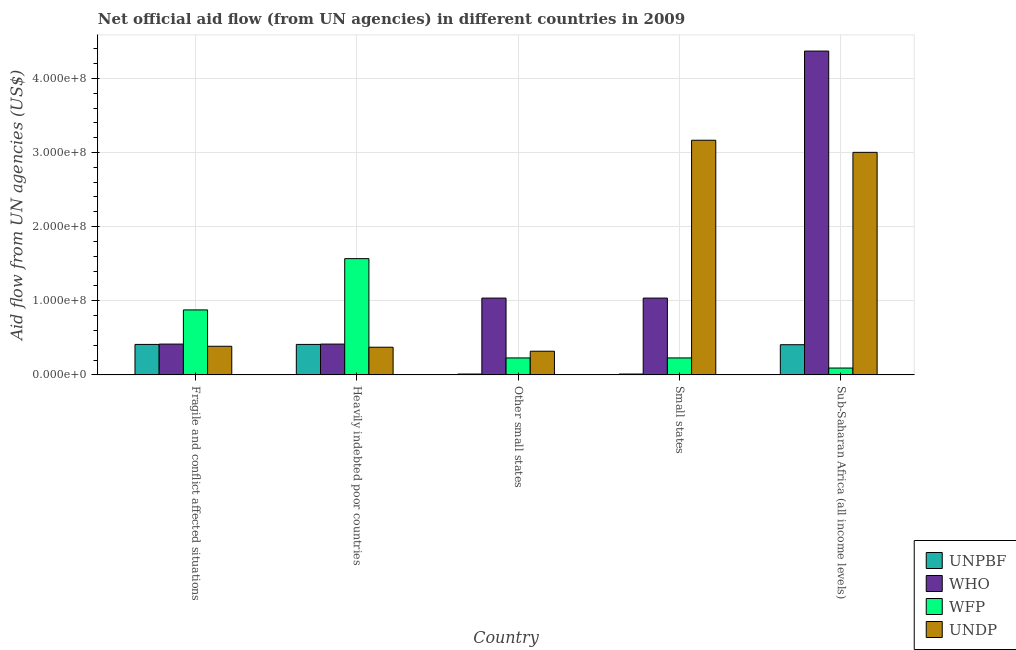How many different coloured bars are there?
Offer a terse response. 4. How many groups of bars are there?
Provide a succinct answer. 5. Are the number of bars per tick equal to the number of legend labels?
Your answer should be very brief. Yes. How many bars are there on the 5th tick from the left?
Offer a terse response. 4. How many bars are there on the 5th tick from the right?
Provide a succinct answer. 4. What is the label of the 3rd group of bars from the left?
Give a very brief answer. Other small states. What is the amount of aid given by unpbf in Small states?
Offer a terse response. 1.18e+06. Across all countries, what is the maximum amount of aid given by unpbf?
Give a very brief answer. 4.11e+07. Across all countries, what is the minimum amount of aid given by undp?
Make the answer very short. 3.20e+07. In which country was the amount of aid given by who maximum?
Your answer should be compact. Sub-Saharan Africa (all income levels). In which country was the amount of aid given by wfp minimum?
Your response must be concise. Sub-Saharan Africa (all income levels). What is the total amount of aid given by unpbf in the graph?
Your answer should be compact. 1.25e+08. What is the difference between the amount of aid given by undp in Small states and that in Sub-Saharan Africa (all income levels)?
Provide a succinct answer. 1.63e+07. What is the difference between the amount of aid given by wfp in Sub-Saharan Africa (all income levels) and the amount of aid given by who in Heavily indebted poor countries?
Offer a terse response. -3.23e+07. What is the average amount of aid given by wfp per country?
Your response must be concise. 5.99e+07. What is the difference between the amount of aid given by who and amount of aid given by wfp in Heavily indebted poor countries?
Your answer should be compact. -1.15e+08. In how many countries, is the amount of aid given by who greater than 420000000 US$?
Offer a terse response. 1. What is the ratio of the amount of aid given by unpbf in Heavily indebted poor countries to that in Small states?
Your answer should be very brief. 34.86. What is the difference between the highest and the second highest amount of aid given by who?
Give a very brief answer. 3.33e+08. What is the difference between the highest and the lowest amount of aid given by wfp?
Your response must be concise. 1.48e+08. In how many countries, is the amount of aid given by wfp greater than the average amount of aid given by wfp taken over all countries?
Your response must be concise. 2. Is the sum of the amount of aid given by who in Fragile and conflict affected situations and Other small states greater than the maximum amount of aid given by undp across all countries?
Offer a terse response. No. What does the 2nd bar from the left in Sub-Saharan Africa (all income levels) represents?
Provide a short and direct response. WHO. What does the 4th bar from the right in Small states represents?
Ensure brevity in your answer.  UNPBF. How many bars are there?
Your answer should be very brief. 20. Are all the bars in the graph horizontal?
Offer a very short reply. No. Are the values on the major ticks of Y-axis written in scientific E-notation?
Your answer should be compact. Yes. Does the graph contain grids?
Make the answer very short. Yes. Where does the legend appear in the graph?
Give a very brief answer. Bottom right. How are the legend labels stacked?
Provide a succinct answer. Vertical. What is the title of the graph?
Ensure brevity in your answer.  Net official aid flow (from UN agencies) in different countries in 2009. What is the label or title of the X-axis?
Give a very brief answer. Country. What is the label or title of the Y-axis?
Offer a very short reply. Aid flow from UN agencies (US$). What is the Aid flow from UN agencies (US$) of UNPBF in Fragile and conflict affected situations?
Ensure brevity in your answer.  4.11e+07. What is the Aid flow from UN agencies (US$) in WHO in Fragile and conflict affected situations?
Give a very brief answer. 4.16e+07. What is the Aid flow from UN agencies (US$) in WFP in Fragile and conflict affected situations?
Offer a very short reply. 8.77e+07. What is the Aid flow from UN agencies (US$) of UNDP in Fragile and conflict affected situations?
Make the answer very short. 3.86e+07. What is the Aid flow from UN agencies (US$) in UNPBF in Heavily indebted poor countries?
Ensure brevity in your answer.  4.11e+07. What is the Aid flow from UN agencies (US$) in WHO in Heavily indebted poor countries?
Ensure brevity in your answer.  4.16e+07. What is the Aid flow from UN agencies (US$) in WFP in Heavily indebted poor countries?
Offer a terse response. 1.57e+08. What is the Aid flow from UN agencies (US$) in UNDP in Heavily indebted poor countries?
Offer a very short reply. 3.74e+07. What is the Aid flow from UN agencies (US$) in UNPBF in Other small states?
Offer a very short reply. 1.18e+06. What is the Aid flow from UN agencies (US$) in WHO in Other small states?
Keep it short and to the point. 1.04e+08. What is the Aid flow from UN agencies (US$) in WFP in Other small states?
Your response must be concise. 2.29e+07. What is the Aid flow from UN agencies (US$) of UNDP in Other small states?
Offer a terse response. 3.20e+07. What is the Aid flow from UN agencies (US$) of UNPBF in Small states?
Provide a succinct answer. 1.18e+06. What is the Aid flow from UN agencies (US$) of WHO in Small states?
Make the answer very short. 1.04e+08. What is the Aid flow from UN agencies (US$) in WFP in Small states?
Provide a succinct answer. 2.29e+07. What is the Aid flow from UN agencies (US$) of UNDP in Small states?
Your response must be concise. 3.17e+08. What is the Aid flow from UN agencies (US$) of UNPBF in Sub-Saharan Africa (all income levels)?
Give a very brief answer. 4.07e+07. What is the Aid flow from UN agencies (US$) in WHO in Sub-Saharan Africa (all income levels)?
Your answer should be very brief. 4.37e+08. What is the Aid flow from UN agencies (US$) in WFP in Sub-Saharan Africa (all income levels)?
Offer a terse response. 9.28e+06. What is the Aid flow from UN agencies (US$) in UNDP in Sub-Saharan Africa (all income levels)?
Offer a terse response. 3.00e+08. Across all countries, what is the maximum Aid flow from UN agencies (US$) of UNPBF?
Offer a very short reply. 4.11e+07. Across all countries, what is the maximum Aid flow from UN agencies (US$) of WHO?
Your answer should be very brief. 4.37e+08. Across all countries, what is the maximum Aid flow from UN agencies (US$) in WFP?
Give a very brief answer. 1.57e+08. Across all countries, what is the maximum Aid flow from UN agencies (US$) in UNDP?
Your answer should be very brief. 3.17e+08. Across all countries, what is the minimum Aid flow from UN agencies (US$) in UNPBF?
Offer a terse response. 1.18e+06. Across all countries, what is the minimum Aid flow from UN agencies (US$) in WHO?
Keep it short and to the point. 4.16e+07. Across all countries, what is the minimum Aid flow from UN agencies (US$) in WFP?
Provide a short and direct response. 9.28e+06. Across all countries, what is the minimum Aid flow from UN agencies (US$) in UNDP?
Your answer should be very brief. 3.20e+07. What is the total Aid flow from UN agencies (US$) in UNPBF in the graph?
Your response must be concise. 1.25e+08. What is the total Aid flow from UN agencies (US$) in WHO in the graph?
Your answer should be very brief. 7.27e+08. What is the total Aid flow from UN agencies (US$) of WFP in the graph?
Your answer should be very brief. 3.00e+08. What is the total Aid flow from UN agencies (US$) of UNDP in the graph?
Your answer should be very brief. 7.25e+08. What is the difference between the Aid flow from UN agencies (US$) of UNPBF in Fragile and conflict affected situations and that in Heavily indebted poor countries?
Your answer should be very brief. 0. What is the difference between the Aid flow from UN agencies (US$) of WFP in Fragile and conflict affected situations and that in Heavily indebted poor countries?
Offer a terse response. -6.92e+07. What is the difference between the Aid flow from UN agencies (US$) in UNDP in Fragile and conflict affected situations and that in Heavily indebted poor countries?
Offer a terse response. 1.28e+06. What is the difference between the Aid flow from UN agencies (US$) in UNPBF in Fragile and conflict affected situations and that in Other small states?
Your answer should be compact. 4.00e+07. What is the difference between the Aid flow from UN agencies (US$) of WHO in Fragile and conflict affected situations and that in Other small states?
Your response must be concise. -6.20e+07. What is the difference between the Aid flow from UN agencies (US$) in WFP in Fragile and conflict affected situations and that in Other small states?
Your response must be concise. 6.48e+07. What is the difference between the Aid flow from UN agencies (US$) in UNDP in Fragile and conflict affected situations and that in Other small states?
Make the answer very short. 6.68e+06. What is the difference between the Aid flow from UN agencies (US$) in UNPBF in Fragile and conflict affected situations and that in Small states?
Give a very brief answer. 4.00e+07. What is the difference between the Aid flow from UN agencies (US$) in WHO in Fragile and conflict affected situations and that in Small states?
Your answer should be very brief. -6.20e+07. What is the difference between the Aid flow from UN agencies (US$) in WFP in Fragile and conflict affected situations and that in Small states?
Give a very brief answer. 6.48e+07. What is the difference between the Aid flow from UN agencies (US$) of UNDP in Fragile and conflict affected situations and that in Small states?
Your answer should be compact. -2.78e+08. What is the difference between the Aid flow from UN agencies (US$) in WHO in Fragile and conflict affected situations and that in Sub-Saharan Africa (all income levels)?
Provide a succinct answer. -3.95e+08. What is the difference between the Aid flow from UN agencies (US$) of WFP in Fragile and conflict affected situations and that in Sub-Saharan Africa (all income levels)?
Provide a succinct answer. 7.84e+07. What is the difference between the Aid flow from UN agencies (US$) of UNDP in Fragile and conflict affected situations and that in Sub-Saharan Africa (all income levels)?
Your answer should be very brief. -2.62e+08. What is the difference between the Aid flow from UN agencies (US$) in UNPBF in Heavily indebted poor countries and that in Other small states?
Give a very brief answer. 4.00e+07. What is the difference between the Aid flow from UN agencies (US$) of WHO in Heavily indebted poor countries and that in Other small states?
Ensure brevity in your answer.  -6.20e+07. What is the difference between the Aid flow from UN agencies (US$) in WFP in Heavily indebted poor countries and that in Other small states?
Give a very brief answer. 1.34e+08. What is the difference between the Aid flow from UN agencies (US$) of UNDP in Heavily indebted poor countries and that in Other small states?
Offer a very short reply. 5.40e+06. What is the difference between the Aid flow from UN agencies (US$) of UNPBF in Heavily indebted poor countries and that in Small states?
Your answer should be very brief. 4.00e+07. What is the difference between the Aid flow from UN agencies (US$) in WHO in Heavily indebted poor countries and that in Small states?
Your answer should be compact. -6.20e+07. What is the difference between the Aid flow from UN agencies (US$) of WFP in Heavily indebted poor countries and that in Small states?
Make the answer very short. 1.34e+08. What is the difference between the Aid flow from UN agencies (US$) in UNDP in Heavily indebted poor countries and that in Small states?
Offer a very short reply. -2.79e+08. What is the difference between the Aid flow from UN agencies (US$) of UNPBF in Heavily indebted poor countries and that in Sub-Saharan Africa (all income levels)?
Provide a short and direct response. 4.00e+05. What is the difference between the Aid flow from UN agencies (US$) of WHO in Heavily indebted poor countries and that in Sub-Saharan Africa (all income levels)?
Your response must be concise. -3.95e+08. What is the difference between the Aid flow from UN agencies (US$) of WFP in Heavily indebted poor countries and that in Sub-Saharan Africa (all income levels)?
Provide a short and direct response. 1.48e+08. What is the difference between the Aid flow from UN agencies (US$) in UNDP in Heavily indebted poor countries and that in Sub-Saharan Africa (all income levels)?
Ensure brevity in your answer.  -2.63e+08. What is the difference between the Aid flow from UN agencies (US$) in UNPBF in Other small states and that in Small states?
Give a very brief answer. 0. What is the difference between the Aid flow from UN agencies (US$) in WFP in Other small states and that in Small states?
Provide a short and direct response. 0. What is the difference between the Aid flow from UN agencies (US$) in UNDP in Other small states and that in Small states?
Keep it short and to the point. -2.85e+08. What is the difference between the Aid flow from UN agencies (US$) of UNPBF in Other small states and that in Sub-Saharan Africa (all income levels)?
Make the answer very short. -3.96e+07. What is the difference between the Aid flow from UN agencies (US$) of WHO in Other small states and that in Sub-Saharan Africa (all income levels)?
Your answer should be compact. -3.33e+08. What is the difference between the Aid flow from UN agencies (US$) in WFP in Other small states and that in Sub-Saharan Africa (all income levels)?
Your answer should be compact. 1.36e+07. What is the difference between the Aid flow from UN agencies (US$) of UNDP in Other small states and that in Sub-Saharan Africa (all income levels)?
Your response must be concise. -2.68e+08. What is the difference between the Aid flow from UN agencies (US$) of UNPBF in Small states and that in Sub-Saharan Africa (all income levels)?
Make the answer very short. -3.96e+07. What is the difference between the Aid flow from UN agencies (US$) of WHO in Small states and that in Sub-Saharan Africa (all income levels)?
Offer a terse response. -3.33e+08. What is the difference between the Aid flow from UN agencies (US$) of WFP in Small states and that in Sub-Saharan Africa (all income levels)?
Offer a terse response. 1.36e+07. What is the difference between the Aid flow from UN agencies (US$) in UNDP in Small states and that in Sub-Saharan Africa (all income levels)?
Provide a short and direct response. 1.63e+07. What is the difference between the Aid flow from UN agencies (US$) of UNPBF in Fragile and conflict affected situations and the Aid flow from UN agencies (US$) of WHO in Heavily indebted poor countries?
Keep it short and to the point. -4.30e+05. What is the difference between the Aid flow from UN agencies (US$) in UNPBF in Fragile and conflict affected situations and the Aid flow from UN agencies (US$) in WFP in Heavily indebted poor countries?
Provide a succinct answer. -1.16e+08. What is the difference between the Aid flow from UN agencies (US$) of UNPBF in Fragile and conflict affected situations and the Aid flow from UN agencies (US$) of UNDP in Heavily indebted poor countries?
Provide a short and direct response. 3.79e+06. What is the difference between the Aid flow from UN agencies (US$) of WHO in Fragile and conflict affected situations and the Aid flow from UN agencies (US$) of WFP in Heavily indebted poor countries?
Give a very brief answer. -1.15e+08. What is the difference between the Aid flow from UN agencies (US$) of WHO in Fragile and conflict affected situations and the Aid flow from UN agencies (US$) of UNDP in Heavily indebted poor countries?
Ensure brevity in your answer.  4.22e+06. What is the difference between the Aid flow from UN agencies (US$) of WFP in Fragile and conflict affected situations and the Aid flow from UN agencies (US$) of UNDP in Heavily indebted poor countries?
Provide a short and direct response. 5.03e+07. What is the difference between the Aid flow from UN agencies (US$) in UNPBF in Fragile and conflict affected situations and the Aid flow from UN agencies (US$) in WHO in Other small states?
Offer a terse response. -6.25e+07. What is the difference between the Aid flow from UN agencies (US$) of UNPBF in Fragile and conflict affected situations and the Aid flow from UN agencies (US$) of WFP in Other small states?
Offer a terse response. 1.82e+07. What is the difference between the Aid flow from UN agencies (US$) of UNPBF in Fragile and conflict affected situations and the Aid flow from UN agencies (US$) of UNDP in Other small states?
Provide a succinct answer. 9.19e+06. What is the difference between the Aid flow from UN agencies (US$) in WHO in Fragile and conflict affected situations and the Aid flow from UN agencies (US$) in WFP in Other small states?
Keep it short and to the point. 1.87e+07. What is the difference between the Aid flow from UN agencies (US$) of WHO in Fragile and conflict affected situations and the Aid flow from UN agencies (US$) of UNDP in Other small states?
Your answer should be very brief. 9.62e+06. What is the difference between the Aid flow from UN agencies (US$) of WFP in Fragile and conflict affected situations and the Aid flow from UN agencies (US$) of UNDP in Other small states?
Provide a short and direct response. 5.57e+07. What is the difference between the Aid flow from UN agencies (US$) of UNPBF in Fragile and conflict affected situations and the Aid flow from UN agencies (US$) of WHO in Small states?
Provide a short and direct response. -6.25e+07. What is the difference between the Aid flow from UN agencies (US$) of UNPBF in Fragile and conflict affected situations and the Aid flow from UN agencies (US$) of WFP in Small states?
Keep it short and to the point. 1.82e+07. What is the difference between the Aid flow from UN agencies (US$) in UNPBF in Fragile and conflict affected situations and the Aid flow from UN agencies (US$) in UNDP in Small states?
Offer a terse response. -2.75e+08. What is the difference between the Aid flow from UN agencies (US$) in WHO in Fragile and conflict affected situations and the Aid flow from UN agencies (US$) in WFP in Small states?
Provide a short and direct response. 1.87e+07. What is the difference between the Aid flow from UN agencies (US$) of WHO in Fragile and conflict affected situations and the Aid flow from UN agencies (US$) of UNDP in Small states?
Offer a terse response. -2.75e+08. What is the difference between the Aid flow from UN agencies (US$) of WFP in Fragile and conflict affected situations and the Aid flow from UN agencies (US$) of UNDP in Small states?
Provide a succinct answer. -2.29e+08. What is the difference between the Aid flow from UN agencies (US$) in UNPBF in Fragile and conflict affected situations and the Aid flow from UN agencies (US$) in WHO in Sub-Saharan Africa (all income levels)?
Ensure brevity in your answer.  -3.96e+08. What is the difference between the Aid flow from UN agencies (US$) of UNPBF in Fragile and conflict affected situations and the Aid flow from UN agencies (US$) of WFP in Sub-Saharan Africa (all income levels)?
Ensure brevity in your answer.  3.19e+07. What is the difference between the Aid flow from UN agencies (US$) in UNPBF in Fragile and conflict affected situations and the Aid flow from UN agencies (US$) in UNDP in Sub-Saharan Africa (all income levels)?
Provide a succinct answer. -2.59e+08. What is the difference between the Aid flow from UN agencies (US$) of WHO in Fragile and conflict affected situations and the Aid flow from UN agencies (US$) of WFP in Sub-Saharan Africa (all income levels)?
Your answer should be very brief. 3.23e+07. What is the difference between the Aid flow from UN agencies (US$) in WHO in Fragile and conflict affected situations and the Aid flow from UN agencies (US$) in UNDP in Sub-Saharan Africa (all income levels)?
Offer a terse response. -2.59e+08. What is the difference between the Aid flow from UN agencies (US$) of WFP in Fragile and conflict affected situations and the Aid flow from UN agencies (US$) of UNDP in Sub-Saharan Africa (all income levels)?
Ensure brevity in your answer.  -2.13e+08. What is the difference between the Aid flow from UN agencies (US$) in UNPBF in Heavily indebted poor countries and the Aid flow from UN agencies (US$) in WHO in Other small states?
Your answer should be compact. -6.25e+07. What is the difference between the Aid flow from UN agencies (US$) in UNPBF in Heavily indebted poor countries and the Aid flow from UN agencies (US$) in WFP in Other small states?
Provide a succinct answer. 1.82e+07. What is the difference between the Aid flow from UN agencies (US$) of UNPBF in Heavily indebted poor countries and the Aid flow from UN agencies (US$) of UNDP in Other small states?
Keep it short and to the point. 9.19e+06. What is the difference between the Aid flow from UN agencies (US$) in WHO in Heavily indebted poor countries and the Aid flow from UN agencies (US$) in WFP in Other small states?
Your answer should be compact. 1.87e+07. What is the difference between the Aid flow from UN agencies (US$) of WHO in Heavily indebted poor countries and the Aid flow from UN agencies (US$) of UNDP in Other small states?
Your answer should be compact. 9.62e+06. What is the difference between the Aid flow from UN agencies (US$) of WFP in Heavily indebted poor countries and the Aid flow from UN agencies (US$) of UNDP in Other small states?
Offer a terse response. 1.25e+08. What is the difference between the Aid flow from UN agencies (US$) in UNPBF in Heavily indebted poor countries and the Aid flow from UN agencies (US$) in WHO in Small states?
Your answer should be compact. -6.25e+07. What is the difference between the Aid flow from UN agencies (US$) in UNPBF in Heavily indebted poor countries and the Aid flow from UN agencies (US$) in WFP in Small states?
Your response must be concise. 1.82e+07. What is the difference between the Aid flow from UN agencies (US$) in UNPBF in Heavily indebted poor countries and the Aid flow from UN agencies (US$) in UNDP in Small states?
Your response must be concise. -2.75e+08. What is the difference between the Aid flow from UN agencies (US$) in WHO in Heavily indebted poor countries and the Aid flow from UN agencies (US$) in WFP in Small states?
Make the answer very short. 1.87e+07. What is the difference between the Aid flow from UN agencies (US$) in WHO in Heavily indebted poor countries and the Aid flow from UN agencies (US$) in UNDP in Small states?
Ensure brevity in your answer.  -2.75e+08. What is the difference between the Aid flow from UN agencies (US$) in WFP in Heavily indebted poor countries and the Aid flow from UN agencies (US$) in UNDP in Small states?
Offer a very short reply. -1.60e+08. What is the difference between the Aid flow from UN agencies (US$) in UNPBF in Heavily indebted poor countries and the Aid flow from UN agencies (US$) in WHO in Sub-Saharan Africa (all income levels)?
Offer a very short reply. -3.96e+08. What is the difference between the Aid flow from UN agencies (US$) of UNPBF in Heavily indebted poor countries and the Aid flow from UN agencies (US$) of WFP in Sub-Saharan Africa (all income levels)?
Provide a succinct answer. 3.19e+07. What is the difference between the Aid flow from UN agencies (US$) of UNPBF in Heavily indebted poor countries and the Aid flow from UN agencies (US$) of UNDP in Sub-Saharan Africa (all income levels)?
Ensure brevity in your answer.  -2.59e+08. What is the difference between the Aid flow from UN agencies (US$) in WHO in Heavily indebted poor countries and the Aid flow from UN agencies (US$) in WFP in Sub-Saharan Africa (all income levels)?
Your response must be concise. 3.23e+07. What is the difference between the Aid flow from UN agencies (US$) of WHO in Heavily indebted poor countries and the Aid flow from UN agencies (US$) of UNDP in Sub-Saharan Africa (all income levels)?
Provide a succinct answer. -2.59e+08. What is the difference between the Aid flow from UN agencies (US$) in WFP in Heavily indebted poor countries and the Aid flow from UN agencies (US$) in UNDP in Sub-Saharan Africa (all income levels)?
Your answer should be compact. -1.43e+08. What is the difference between the Aid flow from UN agencies (US$) of UNPBF in Other small states and the Aid flow from UN agencies (US$) of WHO in Small states?
Provide a short and direct response. -1.02e+08. What is the difference between the Aid flow from UN agencies (US$) in UNPBF in Other small states and the Aid flow from UN agencies (US$) in WFP in Small states?
Offer a very short reply. -2.17e+07. What is the difference between the Aid flow from UN agencies (US$) of UNPBF in Other small states and the Aid flow from UN agencies (US$) of UNDP in Small states?
Your answer should be compact. -3.15e+08. What is the difference between the Aid flow from UN agencies (US$) of WHO in Other small states and the Aid flow from UN agencies (US$) of WFP in Small states?
Your answer should be compact. 8.07e+07. What is the difference between the Aid flow from UN agencies (US$) of WHO in Other small states and the Aid flow from UN agencies (US$) of UNDP in Small states?
Your response must be concise. -2.13e+08. What is the difference between the Aid flow from UN agencies (US$) in WFP in Other small states and the Aid flow from UN agencies (US$) in UNDP in Small states?
Offer a very short reply. -2.94e+08. What is the difference between the Aid flow from UN agencies (US$) in UNPBF in Other small states and the Aid flow from UN agencies (US$) in WHO in Sub-Saharan Africa (all income levels)?
Your response must be concise. -4.36e+08. What is the difference between the Aid flow from UN agencies (US$) in UNPBF in Other small states and the Aid flow from UN agencies (US$) in WFP in Sub-Saharan Africa (all income levels)?
Keep it short and to the point. -8.10e+06. What is the difference between the Aid flow from UN agencies (US$) of UNPBF in Other small states and the Aid flow from UN agencies (US$) of UNDP in Sub-Saharan Africa (all income levels)?
Your answer should be very brief. -2.99e+08. What is the difference between the Aid flow from UN agencies (US$) of WHO in Other small states and the Aid flow from UN agencies (US$) of WFP in Sub-Saharan Africa (all income levels)?
Ensure brevity in your answer.  9.43e+07. What is the difference between the Aid flow from UN agencies (US$) of WHO in Other small states and the Aid flow from UN agencies (US$) of UNDP in Sub-Saharan Africa (all income levels)?
Make the answer very short. -1.97e+08. What is the difference between the Aid flow from UN agencies (US$) of WFP in Other small states and the Aid flow from UN agencies (US$) of UNDP in Sub-Saharan Africa (all income levels)?
Give a very brief answer. -2.77e+08. What is the difference between the Aid flow from UN agencies (US$) of UNPBF in Small states and the Aid flow from UN agencies (US$) of WHO in Sub-Saharan Africa (all income levels)?
Offer a very short reply. -4.36e+08. What is the difference between the Aid flow from UN agencies (US$) in UNPBF in Small states and the Aid flow from UN agencies (US$) in WFP in Sub-Saharan Africa (all income levels)?
Your answer should be compact. -8.10e+06. What is the difference between the Aid flow from UN agencies (US$) in UNPBF in Small states and the Aid flow from UN agencies (US$) in UNDP in Sub-Saharan Africa (all income levels)?
Provide a short and direct response. -2.99e+08. What is the difference between the Aid flow from UN agencies (US$) in WHO in Small states and the Aid flow from UN agencies (US$) in WFP in Sub-Saharan Africa (all income levels)?
Provide a short and direct response. 9.43e+07. What is the difference between the Aid flow from UN agencies (US$) in WHO in Small states and the Aid flow from UN agencies (US$) in UNDP in Sub-Saharan Africa (all income levels)?
Your response must be concise. -1.97e+08. What is the difference between the Aid flow from UN agencies (US$) of WFP in Small states and the Aid flow from UN agencies (US$) of UNDP in Sub-Saharan Africa (all income levels)?
Ensure brevity in your answer.  -2.77e+08. What is the average Aid flow from UN agencies (US$) of UNPBF per country?
Give a very brief answer. 2.51e+07. What is the average Aid flow from UN agencies (US$) of WHO per country?
Provide a short and direct response. 1.45e+08. What is the average Aid flow from UN agencies (US$) in WFP per country?
Provide a succinct answer. 5.99e+07. What is the average Aid flow from UN agencies (US$) in UNDP per country?
Give a very brief answer. 1.45e+08. What is the difference between the Aid flow from UN agencies (US$) in UNPBF and Aid flow from UN agencies (US$) in WHO in Fragile and conflict affected situations?
Make the answer very short. -4.30e+05. What is the difference between the Aid flow from UN agencies (US$) in UNPBF and Aid flow from UN agencies (US$) in WFP in Fragile and conflict affected situations?
Provide a succinct answer. -4.65e+07. What is the difference between the Aid flow from UN agencies (US$) in UNPBF and Aid flow from UN agencies (US$) in UNDP in Fragile and conflict affected situations?
Offer a very short reply. 2.51e+06. What is the difference between the Aid flow from UN agencies (US$) of WHO and Aid flow from UN agencies (US$) of WFP in Fragile and conflict affected situations?
Make the answer very short. -4.61e+07. What is the difference between the Aid flow from UN agencies (US$) in WHO and Aid flow from UN agencies (US$) in UNDP in Fragile and conflict affected situations?
Keep it short and to the point. 2.94e+06. What is the difference between the Aid flow from UN agencies (US$) in WFP and Aid flow from UN agencies (US$) in UNDP in Fragile and conflict affected situations?
Offer a very short reply. 4.90e+07. What is the difference between the Aid flow from UN agencies (US$) in UNPBF and Aid flow from UN agencies (US$) in WHO in Heavily indebted poor countries?
Your answer should be very brief. -4.30e+05. What is the difference between the Aid flow from UN agencies (US$) of UNPBF and Aid flow from UN agencies (US$) of WFP in Heavily indebted poor countries?
Your answer should be very brief. -1.16e+08. What is the difference between the Aid flow from UN agencies (US$) of UNPBF and Aid flow from UN agencies (US$) of UNDP in Heavily indebted poor countries?
Keep it short and to the point. 3.79e+06. What is the difference between the Aid flow from UN agencies (US$) of WHO and Aid flow from UN agencies (US$) of WFP in Heavily indebted poor countries?
Make the answer very short. -1.15e+08. What is the difference between the Aid flow from UN agencies (US$) in WHO and Aid flow from UN agencies (US$) in UNDP in Heavily indebted poor countries?
Provide a short and direct response. 4.22e+06. What is the difference between the Aid flow from UN agencies (US$) in WFP and Aid flow from UN agencies (US$) in UNDP in Heavily indebted poor countries?
Provide a succinct answer. 1.19e+08. What is the difference between the Aid flow from UN agencies (US$) in UNPBF and Aid flow from UN agencies (US$) in WHO in Other small states?
Keep it short and to the point. -1.02e+08. What is the difference between the Aid flow from UN agencies (US$) of UNPBF and Aid flow from UN agencies (US$) of WFP in Other small states?
Your answer should be very brief. -2.17e+07. What is the difference between the Aid flow from UN agencies (US$) in UNPBF and Aid flow from UN agencies (US$) in UNDP in Other small states?
Your answer should be very brief. -3.08e+07. What is the difference between the Aid flow from UN agencies (US$) in WHO and Aid flow from UN agencies (US$) in WFP in Other small states?
Keep it short and to the point. 8.07e+07. What is the difference between the Aid flow from UN agencies (US$) of WHO and Aid flow from UN agencies (US$) of UNDP in Other small states?
Keep it short and to the point. 7.17e+07. What is the difference between the Aid flow from UN agencies (US$) in WFP and Aid flow from UN agencies (US$) in UNDP in Other small states?
Your response must be concise. -9.04e+06. What is the difference between the Aid flow from UN agencies (US$) of UNPBF and Aid flow from UN agencies (US$) of WHO in Small states?
Make the answer very short. -1.02e+08. What is the difference between the Aid flow from UN agencies (US$) of UNPBF and Aid flow from UN agencies (US$) of WFP in Small states?
Make the answer very short. -2.17e+07. What is the difference between the Aid flow from UN agencies (US$) in UNPBF and Aid flow from UN agencies (US$) in UNDP in Small states?
Offer a terse response. -3.15e+08. What is the difference between the Aid flow from UN agencies (US$) of WHO and Aid flow from UN agencies (US$) of WFP in Small states?
Your answer should be compact. 8.07e+07. What is the difference between the Aid flow from UN agencies (US$) in WHO and Aid flow from UN agencies (US$) in UNDP in Small states?
Ensure brevity in your answer.  -2.13e+08. What is the difference between the Aid flow from UN agencies (US$) of WFP and Aid flow from UN agencies (US$) of UNDP in Small states?
Offer a very short reply. -2.94e+08. What is the difference between the Aid flow from UN agencies (US$) in UNPBF and Aid flow from UN agencies (US$) in WHO in Sub-Saharan Africa (all income levels)?
Your response must be concise. -3.96e+08. What is the difference between the Aid flow from UN agencies (US$) of UNPBF and Aid flow from UN agencies (US$) of WFP in Sub-Saharan Africa (all income levels)?
Offer a terse response. 3.15e+07. What is the difference between the Aid flow from UN agencies (US$) in UNPBF and Aid flow from UN agencies (US$) in UNDP in Sub-Saharan Africa (all income levels)?
Make the answer very short. -2.59e+08. What is the difference between the Aid flow from UN agencies (US$) in WHO and Aid flow from UN agencies (US$) in WFP in Sub-Saharan Africa (all income levels)?
Your response must be concise. 4.28e+08. What is the difference between the Aid flow from UN agencies (US$) in WHO and Aid flow from UN agencies (US$) in UNDP in Sub-Saharan Africa (all income levels)?
Offer a terse response. 1.37e+08. What is the difference between the Aid flow from UN agencies (US$) of WFP and Aid flow from UN agencies (US$) of UNDP in Sub-Saharan Africa (all income levels)?
Offer a very short reply. -2.91e+08. What is the ratio of the Aid flow from UN agencies (US$) in UNPBF in Fragile and conflict affected situations to that in Heavily indebted poor countries?
Keep it short and to the point. 1. What is the ratio of the Aid flow from UN agencies (US$) of WHO in Fragile and conflict affected situations to that in Heavily indebted poor countries?
Provide a short and direct response. 1. What is the ratio of the Aid flow from UN agencies (US$) of WFP in Fragile and conflict affected situations to that in Heavily indebted poor countries?
Provide a succinct answer. 0.56. What is the ratio of the Aid flow from UN agencies (US$) in UNDP in Fragile and conflict affected situations to that in Heavily indebted poor countries?
Keep it short and to the point. 1.03. What is the ratio of the Aid flow from UN agencies (US$) in UNPBF in Fragile and conflict affected situations to that in Other small states?
Offer a very short reply. 34.86. What is the ratio of the Aid flow from UN agencies (US$) of WHO in Fragile and conflict affected situations to that in Other small states?
Offer a very short reply. 0.4. What is the ratio of the Aid flow from UN agencies (US$) of WFP in Fragile and conflict affected situations to that in Other small states?
Ensure brevity in your answer.  3.83. What is the ratio of the Aid flow from UN agencies (US$) in UNDP in Fragile and conflict affected situations to that in Other small states?
Ensure brevity in your answer.  1.21. What is the ratio of the Aid flow from UN agencies (US$) of UNPBF in Fragile and conflict affected situations to that in Small states?
Your answer should be compact. 34.86. What is the ratio of the Aid flow from UN agencies (US$) of WHO in Fragile and conflict affected situations to that in Small states?
Give a very brief answer. 0.4. What is the ratio of the Aid flow from UN agencies (US$) in WFP in Fragile and conflict affected situations to that in Small states?
Make the answer very short. 3.83. What is the ratio of the Aid flow from UN agencies (US$) of UNDP in Fragile and conflict affected situations to that in Small states?
Your answer should be compact. 0.12. What is the ratio of the Aid flow from UN agencies (US$) of UNPBF in Fragile and conflict affected situations to that in Sub-Saharan Africa (all income levels)?
Your response must be concise. 1.01. What is the ratio of the Aid flow from UN agencies (US$) of WHO in Fragile and conflict affected situations to that in Sub-Saharan Africa (all income levels)?
Give a very brief answer. 0.1. What is the ratio of the Aid flow from UN agencies (US$) in WFP in Fragile and conflict affected situations to that in Sub-Saharan Africa (all income levels)?
Give a very brief answer. 9.45. What is the ratio of the Aid flow from UN agencies (US$) in UNDP in Fragile and conflict affected situations to that in Sub-Saharan Africa (all income levels)?
Offer a very short reply. 0.13. What is the ratio of the Aid flow from UN agencies (US$) of UNPBF in Heavily indebted poor countries to that in Other small states?
Your answer should be compact. 34.86. What is the ratio of the Aid flow from UN agencies (US$) in WHO in Heavily indebted poor countries to that in Other small states?
Provide a short and direct response. 0.4. What is the ratio of the Aid flow from UN agencies (US$) of WFP in Heavily indebted poor countries to that in Other small states?
Provide a short and direct response. 6.85. What is the ratio of the Aid flow from UN agencies (US$) in UNDP in Heavily indebted poor countries to that in Other small states?
Your answer should be compact. 1.17. What is the ratio of the Aid flow from UN agencies (US$) of UNPBF in Heavily indebted poor countries to that in Small states?
Ensure brevity in your answer.  34.86. What is the ratio of the Aid flow from UN agencies (US$) in WHO in Heavily indebted poor countries to that in Small states?
Provide a succinct answer. 0.4. What is the ratio of the Aid flow from UN agencies (US$) in WFP in Heavily indebted poor countries to that in Small states?
Give a very brief answer. 6.85. What is the ratio of the Aid flow from UN agencies (US$) in UNDP in Heavily indebted poor countries to that in Small states?
Your answer should be very brief. 0.12. What is the ratio of the Aid flow from UN agencies (US$) in UNPBF in Heavily indebted poor countries to that in Sub-Saharan Africa (all income levels)?
Keep it short and to the point. 1.01. What is the ratio of the Aid flow from UN agencies (US$) in WHO in Heavily indebted poor countries to that in Sub-Saharan Africa (all income levels)?
Your answer should be compact. 0.1. What is the ratio of the Aid flow from UN agencies (US$) of WFP in Heavily indebted poor countries to that in Sub-Saharan Africa (all income levels)?
Give a very brief answer. 16.9. What is the ratio of the Aid flow from UN agencies (US$) in UNDP in Heavily indebted poor countries to that in Sub-Saharan Africa (all income levels)?
Offer a very short reply. 0.12. What is the ratio of the Aid flow from UN agencies (US$) of WFP in Other small states to that in Small states?
Provide a succinct answer. 1. What is the ratio of the Aid flow from UN agencies (US$) of UNDP in Other small states to that in Small states?
Ensure brevity in your answer.  0.1. What is the ratio of the Aid flow from UN agencies (US$) of UNPBF in Other small states to that in Sub-Saharan Africa (all income levels)?
Your response must be concise. 0.03. What is the ratio of the Aid flow from UN agencies (US$) in WHO in Other small states to that in Sub-Saharan Africa (all income levels)?
Make the answer very short. 0.24. What is the ratio of the Aid flow from UN agencies (US$) in WFP in Other small states to that in Sub-Saharan Africa (all income levels)?
Provide a short and direct response. 2.47. What is the ratio of the Aid flow from UN agencies (US$) of UNDP in Other small states to that in Sub-Saharan Africa (all income levels)?
Keep it short and to the point. 0.11. What is the ratio of the Aid flow from UN agencies (US$) of UNPBF in Small states to that in Sub-Saharan Africa (all income levels)?
Your answer should be very brief. 0.03. What is the ratio of the Aid flow from UN agencies (US$) in WHO in Small states to that in Sub-Saharan Africa (all income levels)?
Keep it short and to the point. 0.24. What is the ratio of the Aid flow from UN agencies (US$) in WFP in Small states to that in Sub-Saharan Africa (all income levels)?
Offer a very short reply. 2.47. What is the ratio of the Aid flow from UN agencies (US$) of UNDP in Small states to that in Sub-Saharan Africa (all income levels)?
Keep it short and to the point. 1.05. What is the difference between the highest and the second highest Aid flow from UN agencies (US$) in WHO?
Your answer should be compact. 3.33e+08. What is the difference between the highest and the second highest Aid flow from UN agencies (US$) of WFP?
Your answer should be very brief. 6.92e+07. What is the difference between the highest and the second highest Aid flow from UN agencies (US$) of UNDP?
Offer a very short reply. 1.63e+07. What is the difference between the highest and the lowest Aid flow from UN agencies (US$) of UNPBF?
Your answer should be compact. 4.00e+07. What is the difference between the highest and the lowest Aid flow from UN agencies (US$) in WHO?
Provide a short and direct response. 3.95e+08. What is the difference between the highest and the lowest Aid flow from UN agencies (US$) of WFP?
Provide a succinct answer. 1.48e+08. What is the difference between the highest and the lowest Aid flow from UN agencies (US$) in UNDP?
Ensure brevity in your answer.  2.85e+08. 